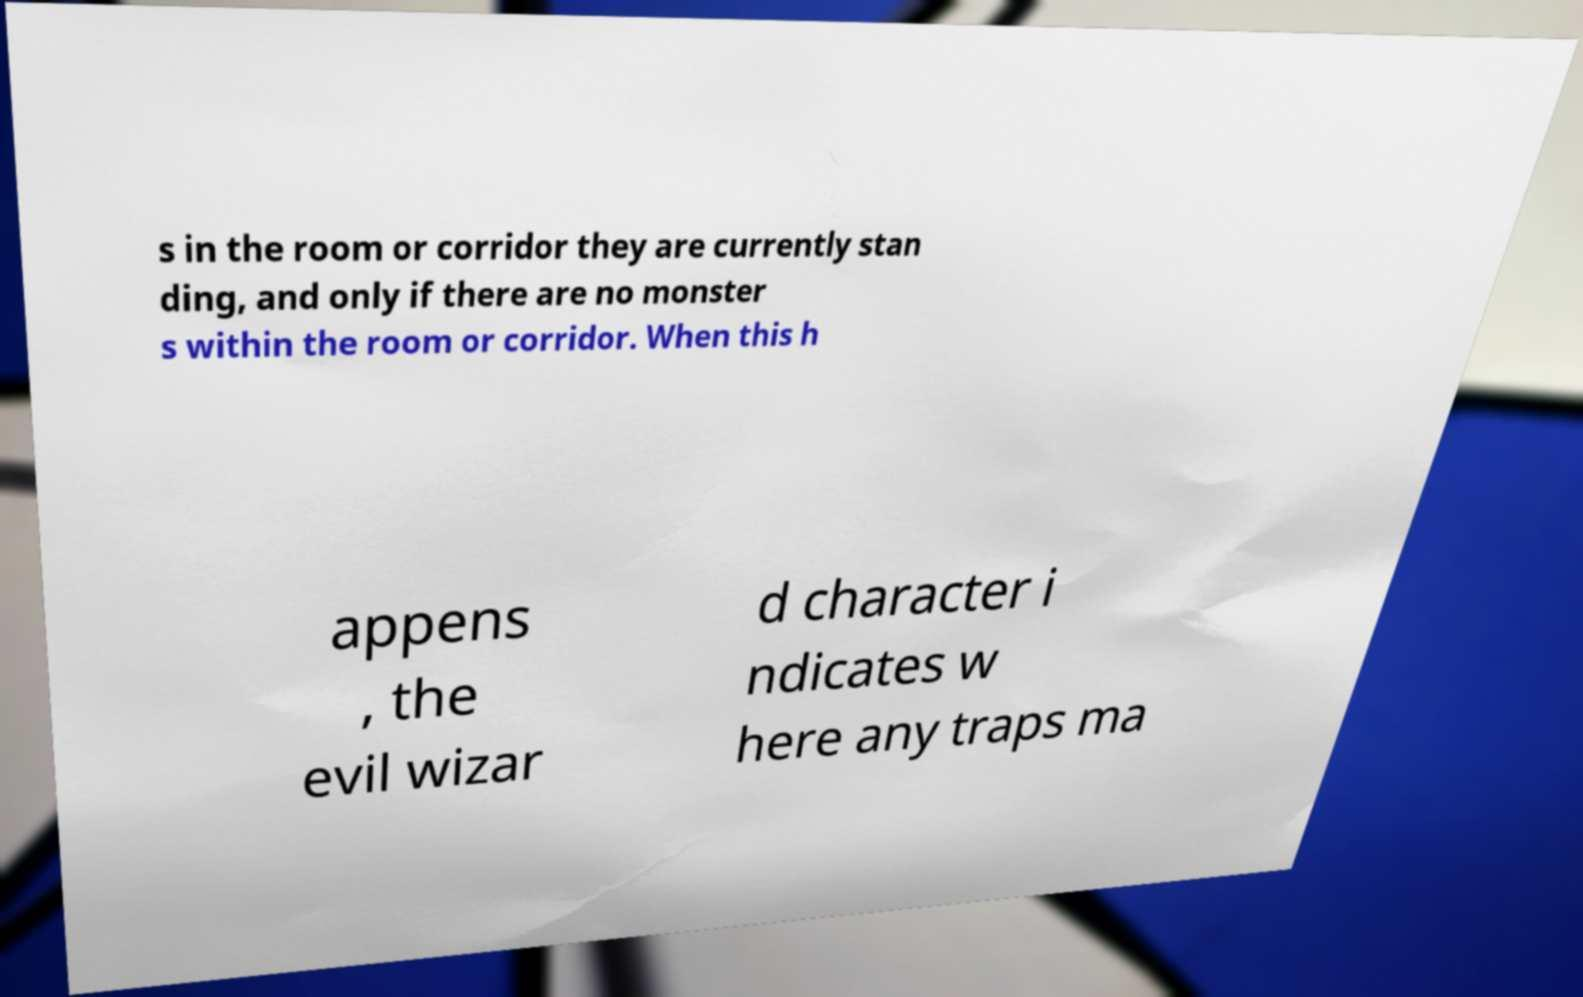Please identify and transcribe the text found in this image. s in the room or corridor they are currently stan ding, and only if there are no monster s within the room or corridor. When this h appens , the evil wizar d character i ndicates w here any traps ma 